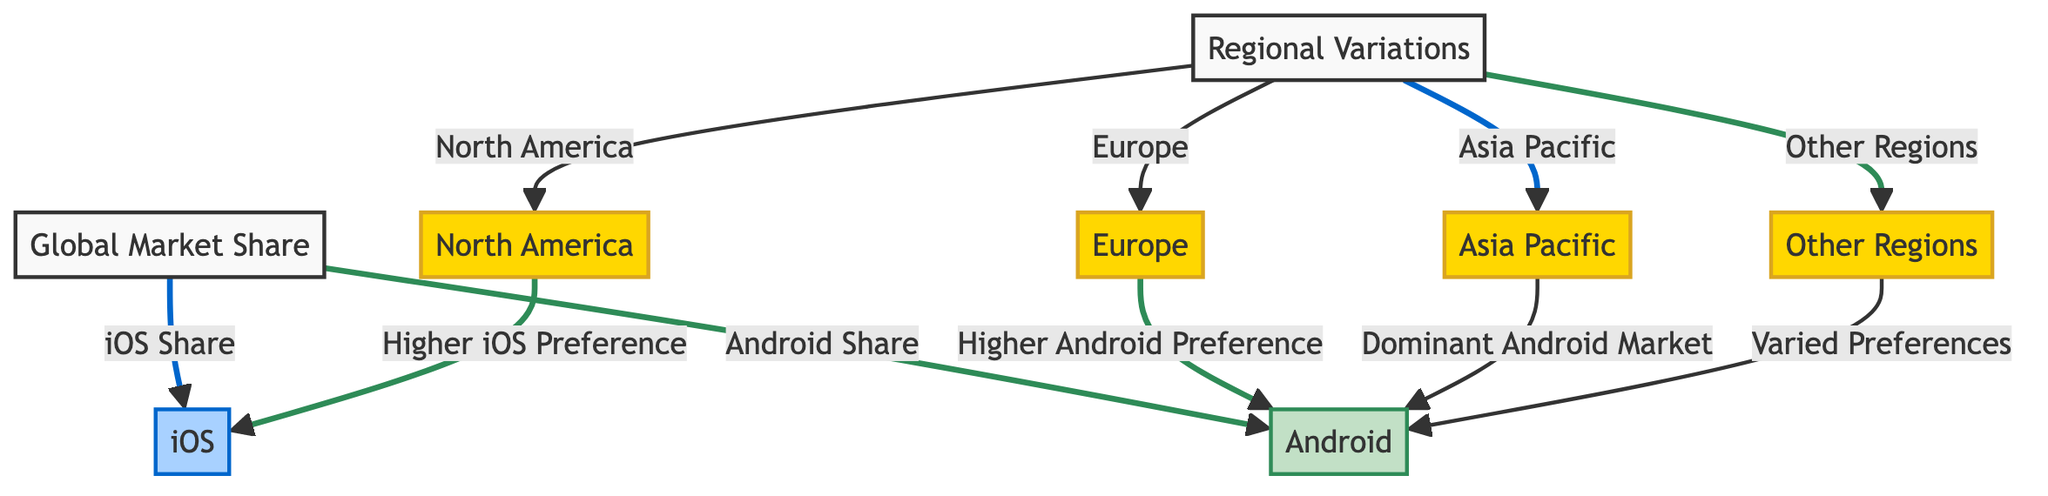What is the dominant operating system for the Asia Pacific region? The Asia Pacific region node directly points to the Android node, indicating that Android is the dominant operating system in this region.
Answer: Android Which region has a higher preference for iOS? The North America node connects to the iOS node, specifying that this region has a higher preference for iOS compared to others.
Answer: North America How many regional variations are identified in this diagram? The diagram includes four nodes representing different regions: North America, Europe, Asia Pacific, and Other Regions. This counts as a total of four distinct regional variations.
Answer: 4 What is indicated by the Other Regions node? The Other Regions node points to Android but mentions "Varied Preferences," showing that this region has diverse preferences for mobile operating systems rather than a strong inclination for one over the other.
Answer: Varied Preferences Is there any indication of a higher Android preference in Europe? The Europe node connects to the Android node, indicating that this region has a higher preference for Android, rather than iOS.
Answer: Yes Which operating system has a broader global market share according to this diagram? The global market share node branches out to both iOS and Android, but without numerical data, this can't be definitively determined from the current structure. The diagram does not specify which has a broader share, so based solely on the diagram, we cannot determine this.
Answer: Not specified What color represents iOS in the diagram? The iOS node is filled with a light blue color (#a8d1ff). This color coding is unique to the iOS node.
Answer: Light blue Which link style denotes a higher preference for iOS? The diagram indicates that the links to the iOS node are depicted in a thicker stroke with the color blue (#0066cc), suggesting a higher preference for iOS.
Answer: Blue stroke How many nodes are directly linked to regional variations? The regional variations node has four directly connected nodes – North America, Europe, Asia Pacific, and Other Regions, indicating the regions being represented.
Answer: 4 